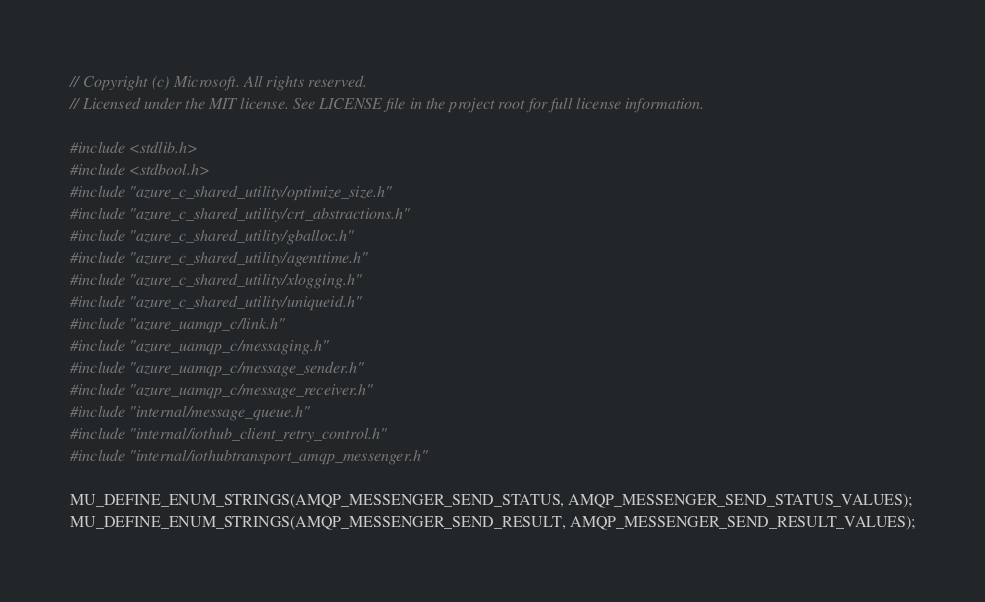<code> <loc_0><loc_0><loc_500><loc_500><_C_>// Copyright (c) Microsoft. All rights reserved.
// Licensed under the MIT license. See LICENSE file in the project root for full license information.

#include <stdlib.h>
#include <stdbool.h>
#include "azure_c_shared_utility/optimize_size.h"
#include "azure_c_shared_utility/crt_abstractions.h"
#include "azure_c_shared_utility/gballoc.h"
#include "azure_c_shared_utility/agenttime.h"
#include "azure_c_shared_utility/xlogging.h"
#include "azure_c_shared_utility/uniqueid.h"
#include "azure_uamqp_c/link.h"
#include "azure_uamqp_c/messaging.h"
#include "azure_uamqp_c/message_sender.h"
#include "azure_uamqp_c/message_receiver.h"
#include "internal/message_queue.h"
#include "internal/iothub_client_retry_control.h"
#include "internal/iothubtransport_amqp_messenger.h"

MU_DEFINE_ENUM_STRINGS(AMQP_MESSENGER_SEND_STATUS, AMQP_MESSENGER_SEND_STATUS_VALUES);
MU_DEFINE_ENUM_STRINGS(AMQP_MESSENGER_SEND_RESULT, AMQP_MESSENGER_SEND_RESULT_VALUES);</code> 